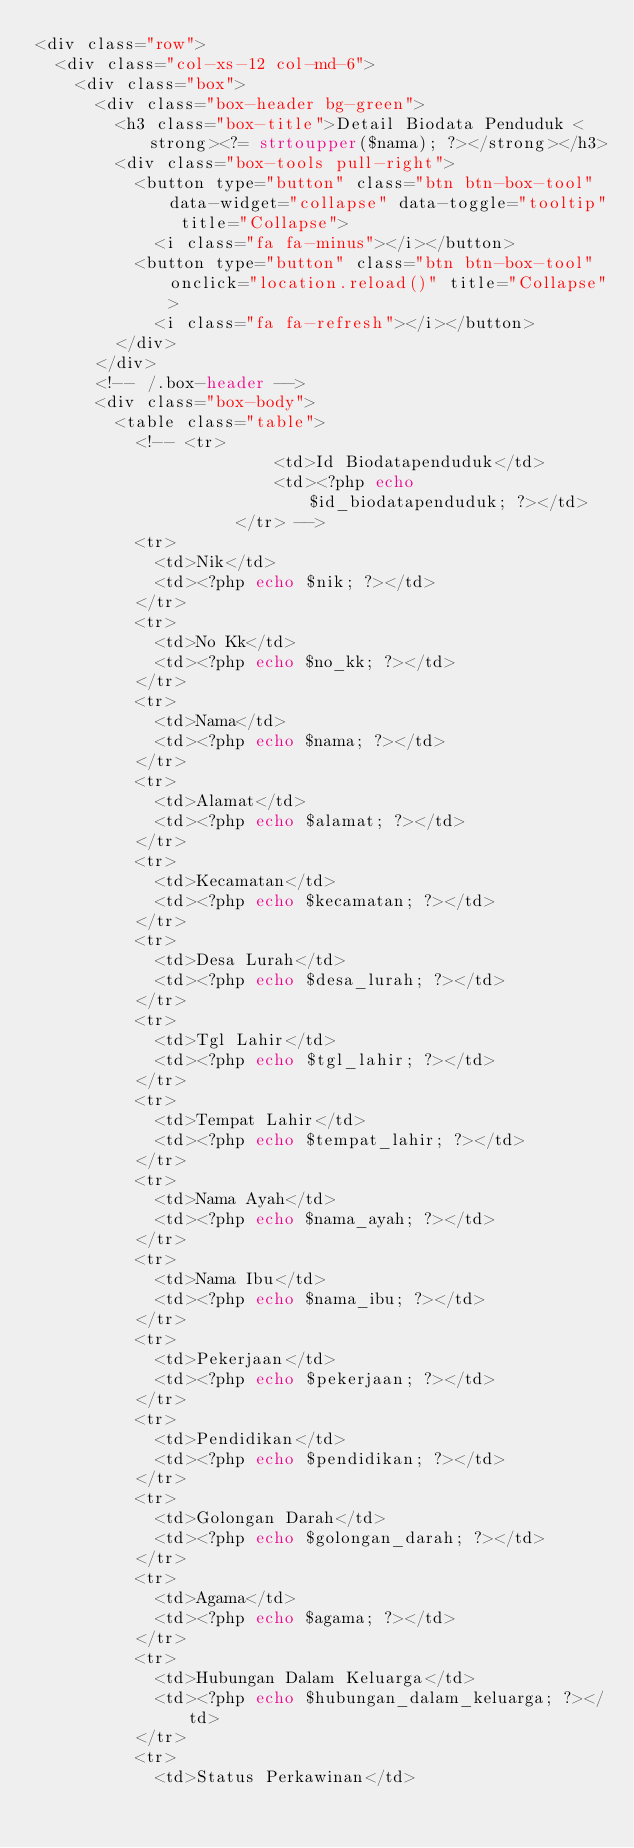<code> <loc_0><loc_0><loc_500><loc_500><_PHP_><div class="row">
  <div class="col-xs-12 col-md-6">
    <div class="box">
      <div class="box-header bg-green">
        <h3 class="box-title">Detail Biodata Penduduk <strong><?= strtoupper($nama); ?></strong></h3>
        <div class="box-tools pull-right">
          <button type="button" class="btn btn-box-tool" data-widget="collapse" data-toggle="tooltip" title="Collapse">
            <i class="fa fa-minus"></i></button>
          <button type="button" class="btn btn-box-tool" onclick="location.reload()" title="Collapse">
            <i class="fa fa-refresh"></i></button>
        </div>
      </div>
      <!-- /.box-header -->
      <div class="box-body">
        <table class="table">
          <!-- <tr>
                        <td>Id Biodatapenduduk</td>
                        <td><?php echo $id_biodatapenduduk; ?></td>
                    </tr> -->
          <tr>
            <td>Nik</td>
            <td><?php echo $nik; ?></td>
          </tr>
          <tr>
            <td>No Kk</td>
            <td><?php echo $no_kk; ?></td>
          </tr>
          <tr>
            <td>Nama</td>
            <td><?php echo $nama; ?></td>
          </tr>
          <tr>
            <td>Alamat</td>
            <td><?php echo $alamat; ?></td>
          </tr>
          <tr>
            <td>Kecamatan</td>
            <td><?php echo $kecamatan; ?></td>
          </tr>
          <tr>
            <td>Desa Lurah</td>
            <td><?php echo $desa_lurah; ?></td>
          </tr>
          <tr>
            <td>Tgl Lahir</td>
            <td><?php echo $tgl_lahir; ?></td>
          </tr>
          <tr>
            <td>Tempat Lahir</td>
            <td><?php echo $tempat_lahir; ?></td>
          </tr>
          <tr>
            <td>Nama Ayah</td>
            <td><?php echo $nama_ayah; ?></td>
          </tr>
          <tr>
            <td>Nama Ibu</td>
            <td><?php echo $nama_ibu; ?></td>
          </tr>
          <tr>
            <td>Pekerjaan</td>
            <td><?php echo $pekerjaan; ?></td>
          </tr>
          <tr>
            <td>Pendidikan</td>
            <td><?php echo $pendidikan; ?></td>
          </tr>
          <tr>
            <td>Golongan Darah</td>
            <td><?php echo $golongan_darah; ?></td>
          </tr>
          <tr>
            <td>Agama</td>
            <td><?php echo $agama; ?></td>
          </tr>
          <tr>
            <td>Hubungan Dalam Keluarga</td>
            <td><?php echo $hubungan_dalam_keluarga; ?></td>
          </tr>
          <tr>
            <td>Status Perkawinan</td></code> 